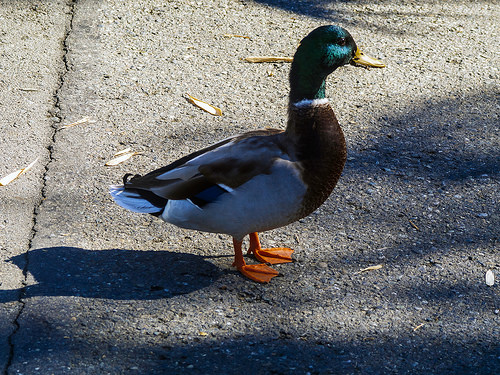<image>
Is there a duck on the ground? Yes. Looking at the image, I can see the duck is positioned on top of the ground, with the ground providing support. Is the duck shoes behind the road? No. The duck shoes is not behind the road. From this viewpoint, the duck shoes appears to be positioned elsewhere in the scene. Is there a bird to the right of the bird shadow? Yes. From this viewpoint, the bird is positioned to the right side relative to the bird shadow. 